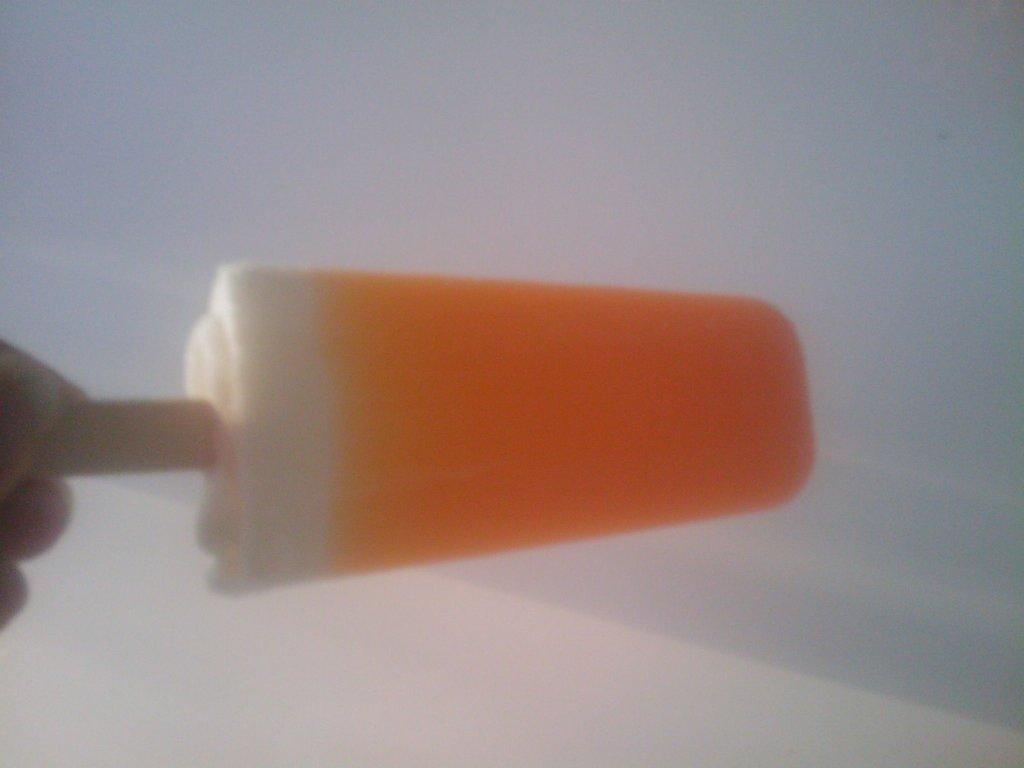What is the main subject of the image? The main subject of the image is a human hand holding an ice-cream. What can be seen in the background of the image? The background of the image is white. What type of silk is being used to fly the airplane in the image? There is no airplane or silk present in the image; it features a human hand holding an ice-cream with a white background. 